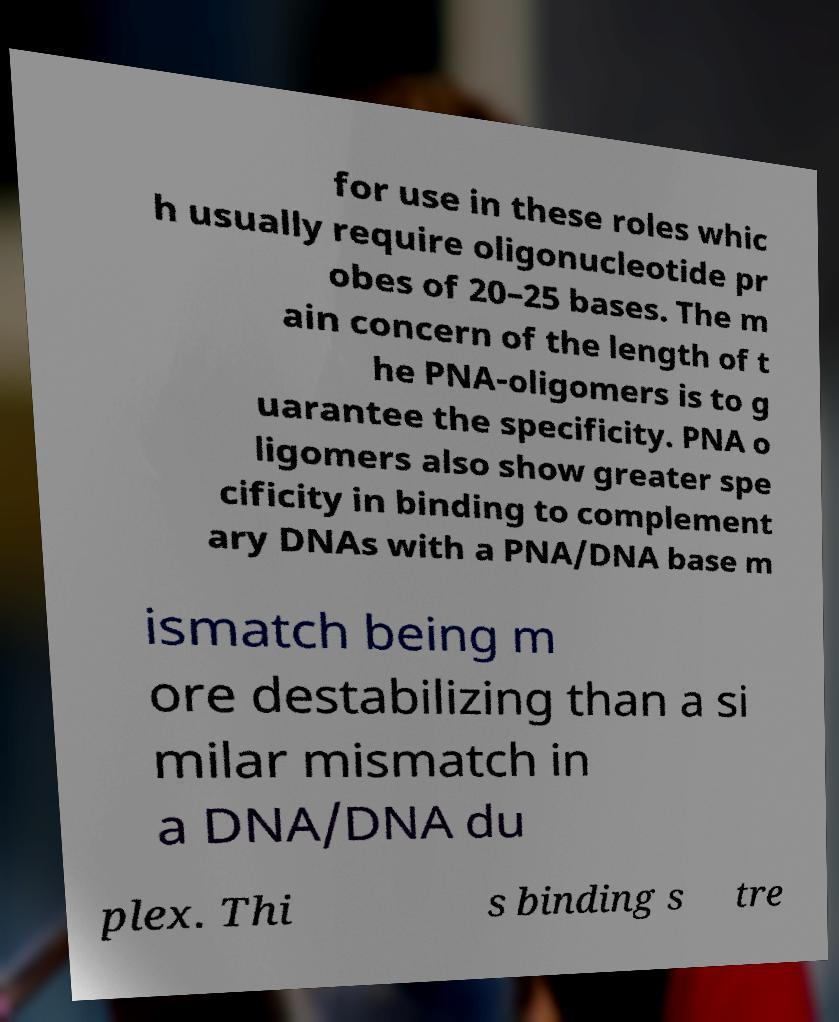What messages or text are displayed in this image? I need them in a readable, typed format. for use in these roles whic h usually require oligonucleotide pr obes of 20–25 bases. The m ain concern of the length of t he PNA-oligomers is to g uarantee the specificity. PNA o ligomers also show greater spe cificity in binding to complement ary DNAs with a PNA/DNA base m ismatch being m ore destabilizing than a si milar mismatch in a DNA/DNA du plex. Thi s binding s tre 